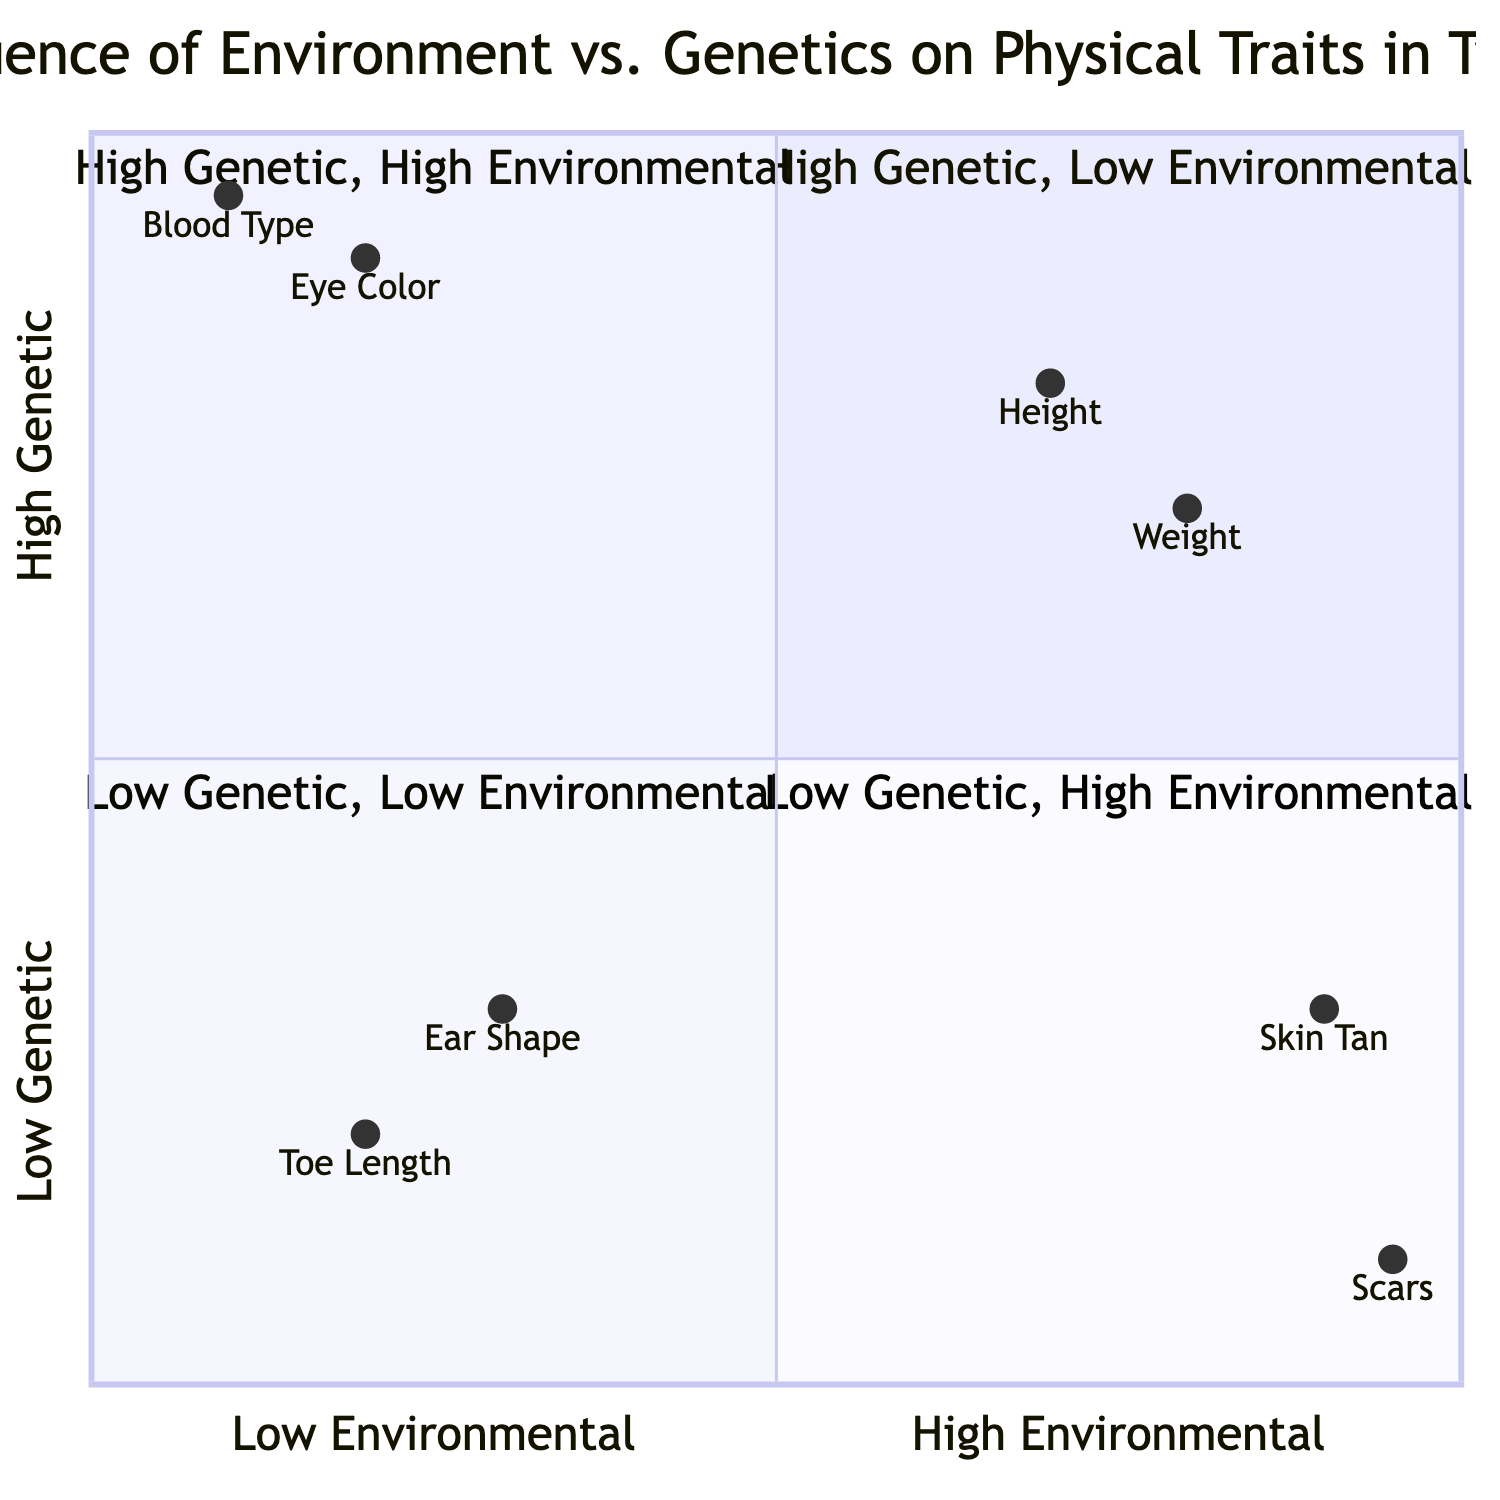What physical trait is in the Top-Left quadrant? The Top-Left quadrant is labeled "High Genetic, Low Environmental". The elements in this quadrant are "Eye Color" and "Blood Type". Therefore, one of the physical traits is "Eye Color".
Answer: Eye Color Which trait is primarily influenced by nutrition and health? In the Top-Right quadrant labeled "High Genetic, High Environmental", "Height" is described as having a strong genetic basis but can be influenced by nutrition and health during developmental years.
Answer: Height How many elements are in the Bottom-Right quadrant? The Bottom-Right quadrant is labeled "Low Genetic, High Environmental" and contains two elements: "Skin Tan" and "Scars". Hence, the count of elements is two.
Answer: 2 What trait shows minimal variation due to genetic influence? The Bottom-Left quadrant is labeled "Low Genetic, Low Environmental". The traits listed are "Ear Shape" and "Toe Length", both have minimal noticeable variation due to genetics or environment. Therefore, one example is "Ear Shape".
Answer: Ear Shape What is the environmental factor primarily affecting "Skin Tan"? The description of "Skin Tan" in the Bottom-Right quadrant indicates that it is largely influenced by sun exposure, thus the key environmental factor is "sun exposure".
Answer: sun exposure List a trait in the Low Genetic, Low Environmental quadrant. The Bottom-Left quadrant includes "Ear Shape" and "Toe Length". Thus, one trait from that quadrant is "Toe Length".
Answer: Toe Length Which trait is affected by lifestyle? In the Top-Right quadrant, "Weight" is mentioned as being genetically predisposed but significantly affected by diet, exercise, and lifestyle; therefore, it is the relevant trait.
Answer: Weight What characterizes traits in the Top-Left quadrant? The Top-Left quadrant is characterized by traits that are high in genetic influence and low in environmental influence, with elements like "Eye Color" and "Blood Type".
Answer: High Genetic, Low Environmental 